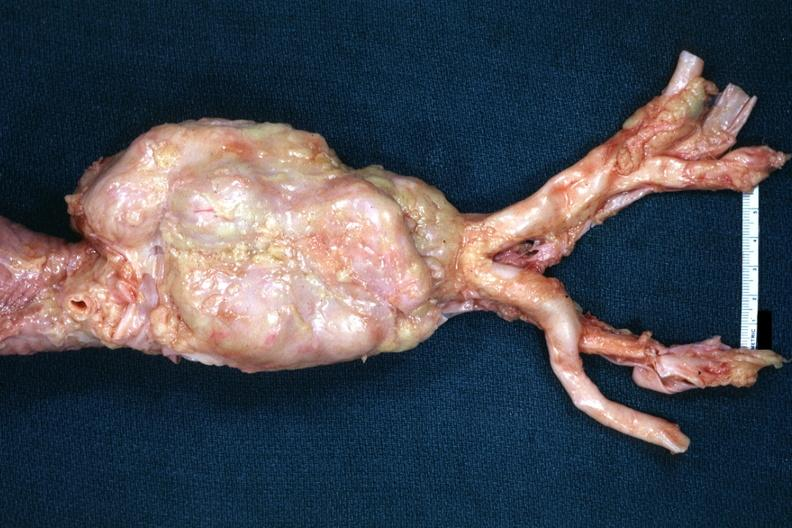what is present?
Answer the question using a single word or phrase. Hodgkins disease 